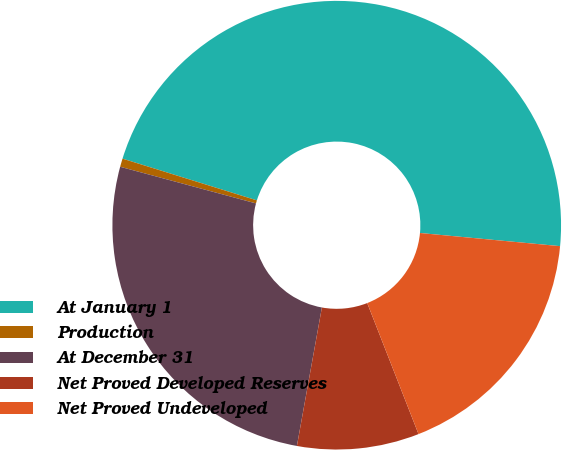Convert chart. <chart><loc_0><loc_0><loc_500><loc_500><pie_chart><fcel>At January 1<fcel>Production<fcel>At December 31<fcel>Net Proved Developed Reserves<fcel>Net Proved Undeveloped<nl><fcel>46.69%<fcel>0.6%<fcel>26.35%<fcel>8.78%<fcel>17.57%<nl></chart> 